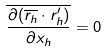Convert formula to latex. <formula><loc_0><loc_0><loc_500><loc_500>\overline { \frac { \partial ( \overline { r _ { h } } \cdot r _ { h } ^ { \prime } ) } { \partial x _ { h } } } = 0</formula> 